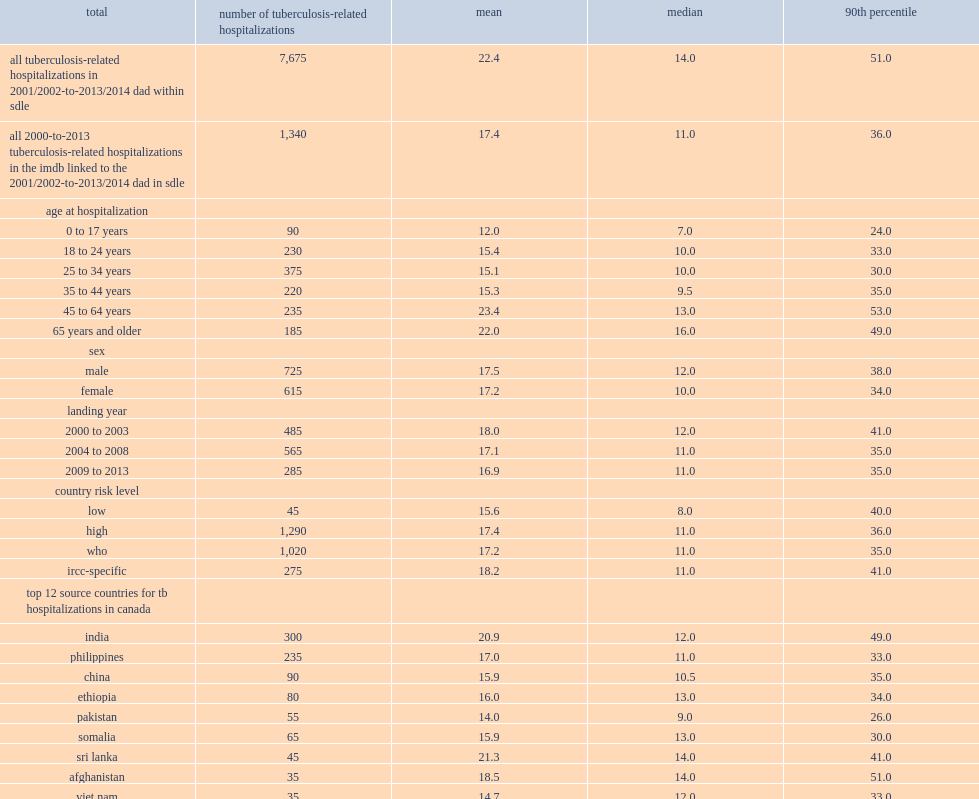How many days of the overall mean length of stay for all tb-related hospitalizations? 22.4. How many days of the overall median length of stay for all tb-related hospitalizations? 14.0. How many days of the avergae mean length among the new immigrant cohort from 2001 to 2013? 17.4. How many days of the avergae median length among the new immigrant cohort from 2001 to 2013? 11.0. What was the mean length of stay in high-risk counties? 17.4. What was the mean length of stay in low-risk counties? 15.6. What was the median length of stay in high-risk counties? 11.0. What was the median length of stay in low-risk counties? 8.0. Which country of new immigrants had the highest mean length of stay? Sudan. Which countries of new immigrants had the highest median length of stay? Sri lanka afghanistan. 